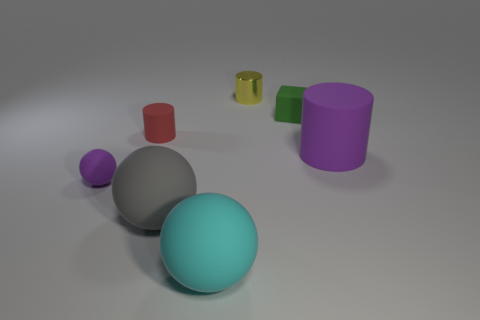The cylinder that is both in front of the block and on the left side of the tiny rubber cube is made of what material?
Your response must be concise. Rubber. What is the color of the matte cylinder that is left of the purple thing behind the tiny thing on the left side of the red matte object?
Provide a succinct answer. Red. The cylinder that is the same size as the metal object is what color?
Provide a succinct answer. Red. Is the color of the tiny ball the same as the matte object that is behind the red rubber cylinder?
Provide a short and direct response. No. There is a small red thing to the right of the tiny thing in front of the tiny red matte cylinder; what is its material?
Provide a succinct answer. Rubber. How many cylinders are both in front of the red cylinder and behind the green cube?
Provide a short and direct response. 0. How many other things are there of the same size as the yellow cylinder?
Provide a short and direct response. 3. Is the shape of the gray rubber object left of the big purple matte cylinder the same as the small matte object that is right of the cyan sphere?
Your answer should be very brief. No. Are there any spheres on the right side of the tiny cube?
Make the answer very short. No. There is another big thing that is the same shape as the gray object; what is its color?
Keep it short and to the point. Cyan. 